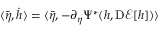Convert formula to latex. <formula><loc_0><loc_0><loc_500><loc_500>\langle \bar { \eta } , \dot { h } \rangle = \langle \bar { \eta } , - \partial _ { \eta } \Psi ^ { * } ( h , D \mathcal { E } [ h ] ) \rangle</formula> 